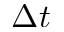Convert formula to latex. <formula><loc_0><loc_0><loc_500><loc_500>\Delta t</formula> 